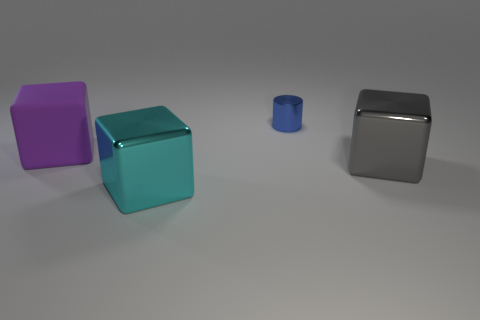Add 4 big cyan shiny spheres. How many objects exist? 8 Subtract all cylinders. How many objects are left? 3 Add 2 tiny purple matte cubes. How many tiny purple matte cubes exist? 2 Subtract 0 purple balls. How many objects are left? 4 Subtract all small red matte cubes. Subtract all purple rubber blocks. How many objects are left? 3 Add 4 blue objects. How many blue objects are left? 5 